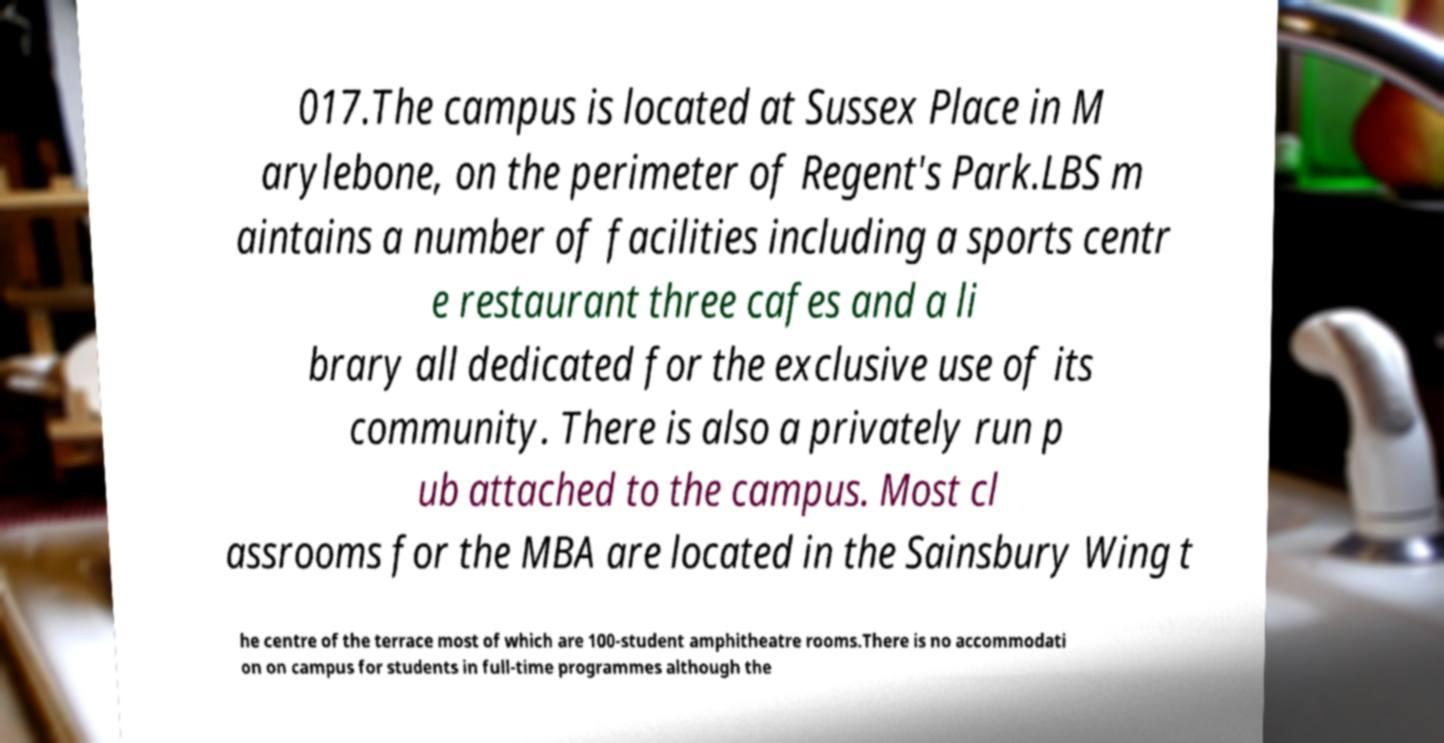Please read and relay the text visible in this image. What does it say? 017.The campus is located at Sussex Place in M arylebone, on the perimeter of Regent's Park.LBS m aintains a number of facilities including a sports centr e restaurant three cafes and a li brary all dedicated for the exclusive use of its community. There is also a privately run p ub attached to the campus. Most cl assrooms for the MBA are located in the Sainsbury Wing t he centre of the terrace most of which are 100-student amphitheatre rooms.There is no accommodati on on campus for students in full-time programmes although the 